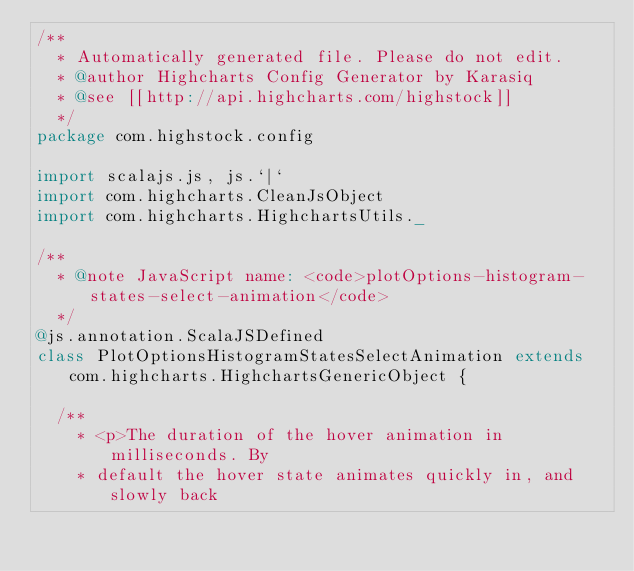Convert code to text. <code><loc_0><loc_0><loc_500><loc_500><_Scala_>/**
  * Automatically generated file. Please do not edit.
  * @author Highcharts Config Generator by Karasiq
  * @see [[http://api.highcharts.com/highstock]]
  */
package com.highstock.config

import scalajs.js, js.`|`
import com.highcharts.CleanJsObject
import com.highcharts.HighchartsUtils._

/**
  * @note JavaScript name: <code>plotOptions-histogram-states-select-animation</code>
  */
@js.annotation.ScalaJSDefined
class PlotOptionsHistogramStatesSelectAnimation extends com.highcharts.HighchartsGenericObject {

  /**
    * <p>The duration of the hover animation in milliseconds. By
    * default the hover state animates quickly in, and slowly back</code> 